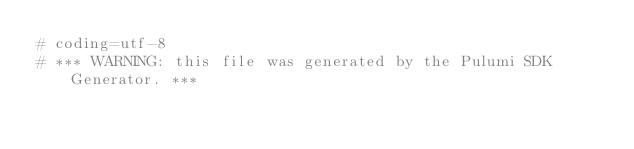Convert code to text. <code><loc_0><loc_0><loc_500><loc_500><_Python_># coding=utf-8
# *** WARNING: this file was generated by the Pulumi SDK Generator. ***</code> 